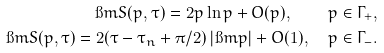Convert formula to latex. <formula><loc_0><loc_0><loc_500><loc_500>\i m S ( p , \tau ) = 2 p \ln p + O ( p ) , \quad p \in \Gamma _ { + } , \\ \i m S ( p , \tau ) = 2 ( \tau - \tau _ { n } + \pi / 2 ) \, | \i m p | + O ( 1 ) , \quad p \in \Gamma _ { - } .</formula> 